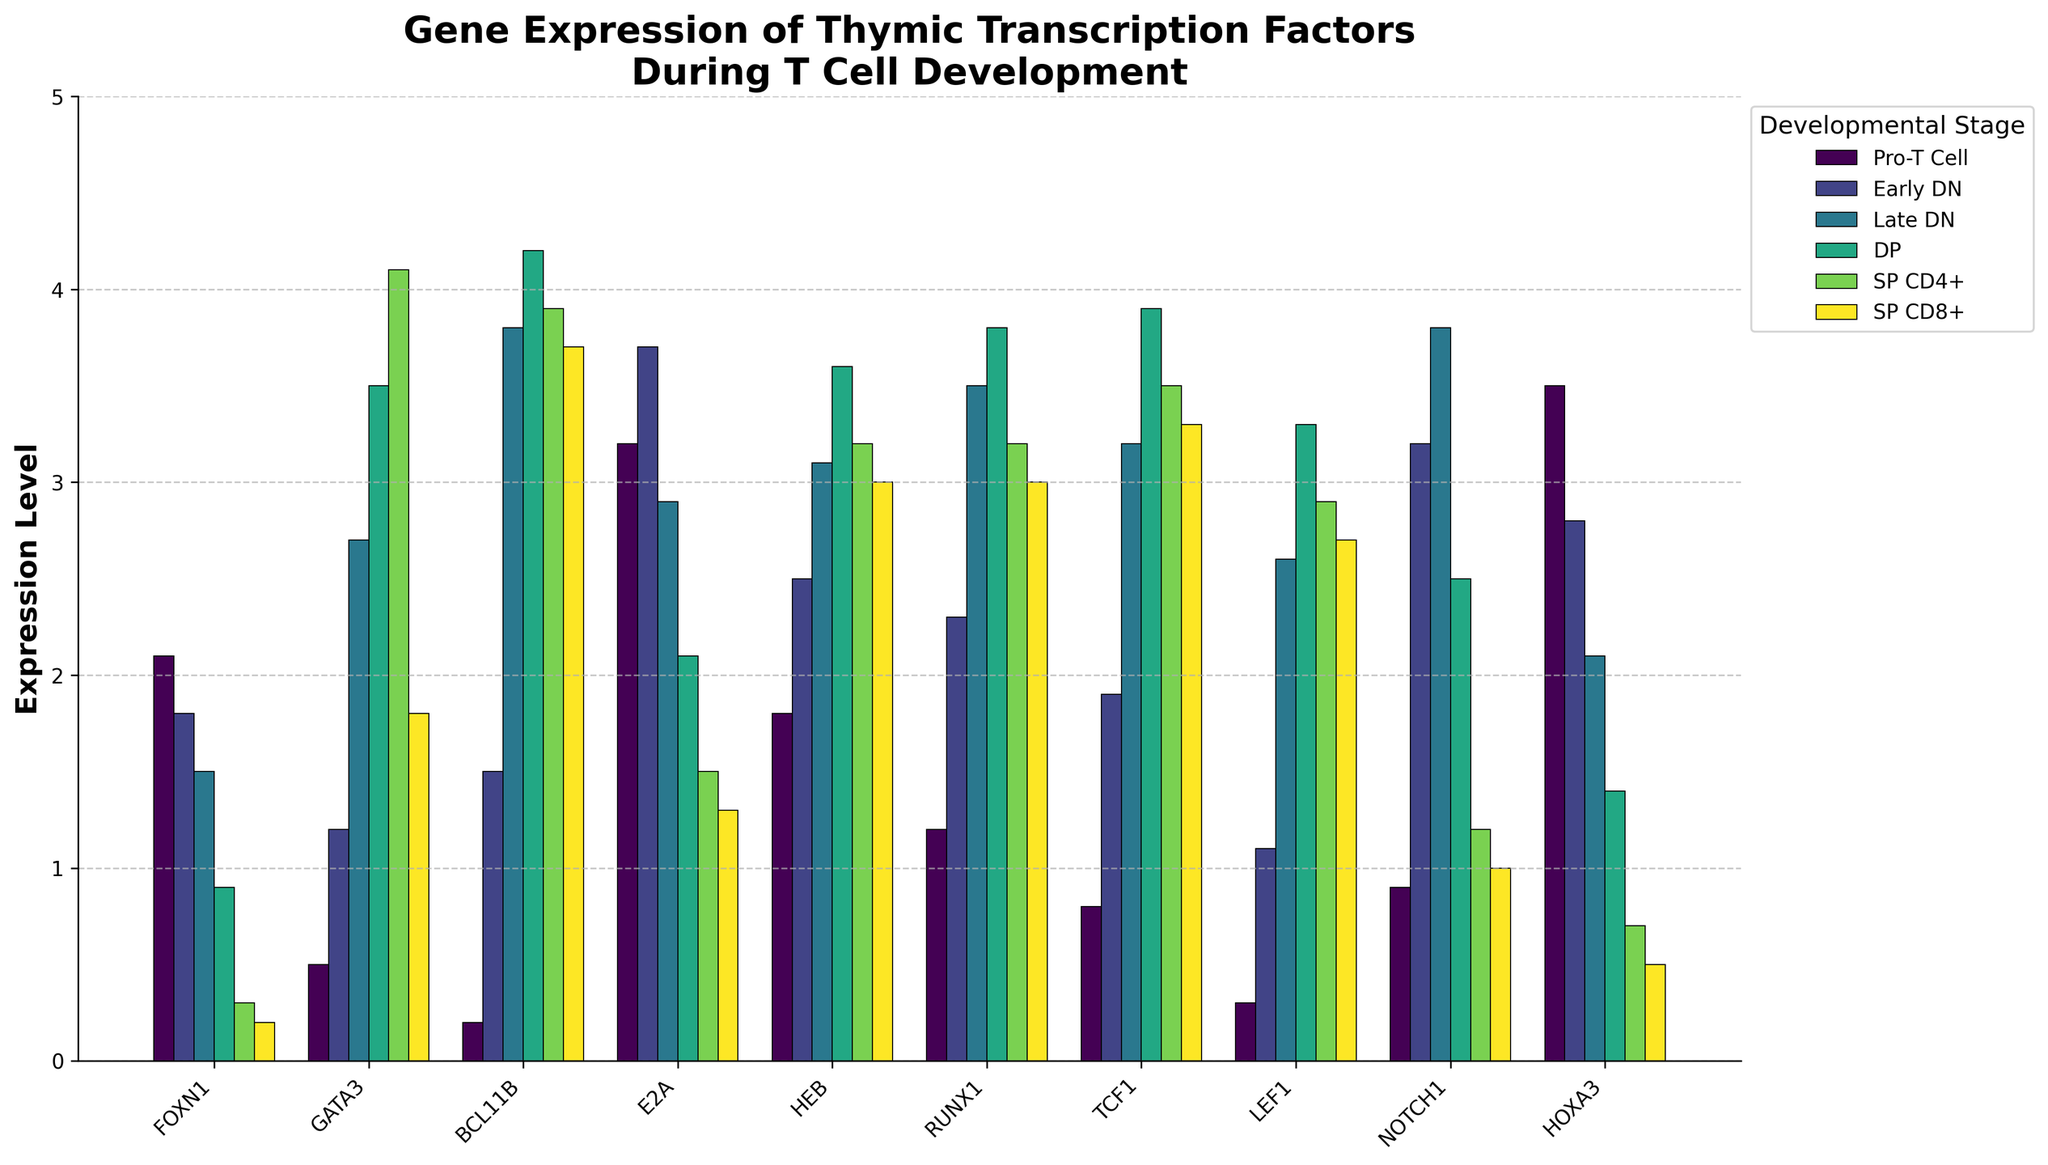What is the expression level of FOXN1 during the Pro-T Cell stage? Locate the bar for FOXN1 under the Pro-T Cell stage. The height of the bar indicates the value.
Answer: 2.1 Which transcription factor has the highest expression level in the DP stage? In the DP stage section, identify the transcription factor with the tallest bar.
Answer: TCF1 At which stage does GATA3 reach its maximum expression? Compare the height of the GATA3 bars across all stages and identify the stage with the tallest bar.
Answer: SP CD4+ How does the expression of HOXA3 change from the Pro-T Cell stage to SP CD8+ stage? Observe the height of the HOXA3 bars from the Pro-T Cell stage to SP CD8+ stage. The height decreases sequentially.
Answer: Decreases What is the average expression level of E2A across all stages? Calculate the sum of E2A expression levels in all stages: 3.2 + 3.7 + 2.9 + 2.1 + 1.5 + 1.3 = 14.7. Divide by the number of stages (6).
Answer: 2.45 Which transcription factor shows the most increase from Pro-T Cell to Late DN stage? Compare the differences in expression levels between the Pro-T Cell and Late DN stages for each transcription factor. Identify the largest increase.
Answer: RUNX1 Between RUNX1 and TCF1, which has a higher expression level in the SP CD4+ stage? Compare the height of the bars for RUNX1 and TCF1 in the SP CD4+ stage.
Answer: TCF1 What is the sum of the expression levels of NOTCH1 in Pro-T Cell and Late DN stages? Add the expression levels of NOTCH1 in Pro-T Cell (0.9) and Late DN (3.8): 0.9 + 3.8 = 4.7.
Answer: 4.7 How does the expression level of LEF1 in the Early DN stage compare to its level in the SP CD8+ stage? Compare the heights of the LEF1 bars in Early DN and SP CD8+ stages.
Answer: Early DN is lower than SP CD8+ 